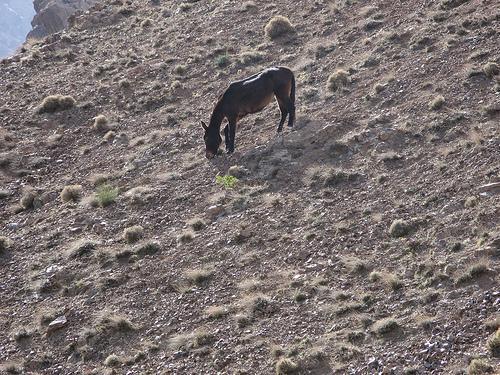How many donkeys are outside?
Give a very brief answer. 1. 